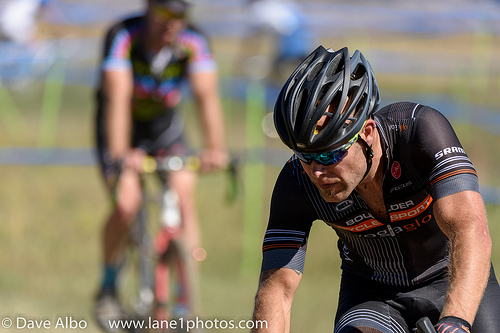<image>
Is there a man in the cycle? No. The man is not contained within the cycle. These objects have a different spatial relationship. 